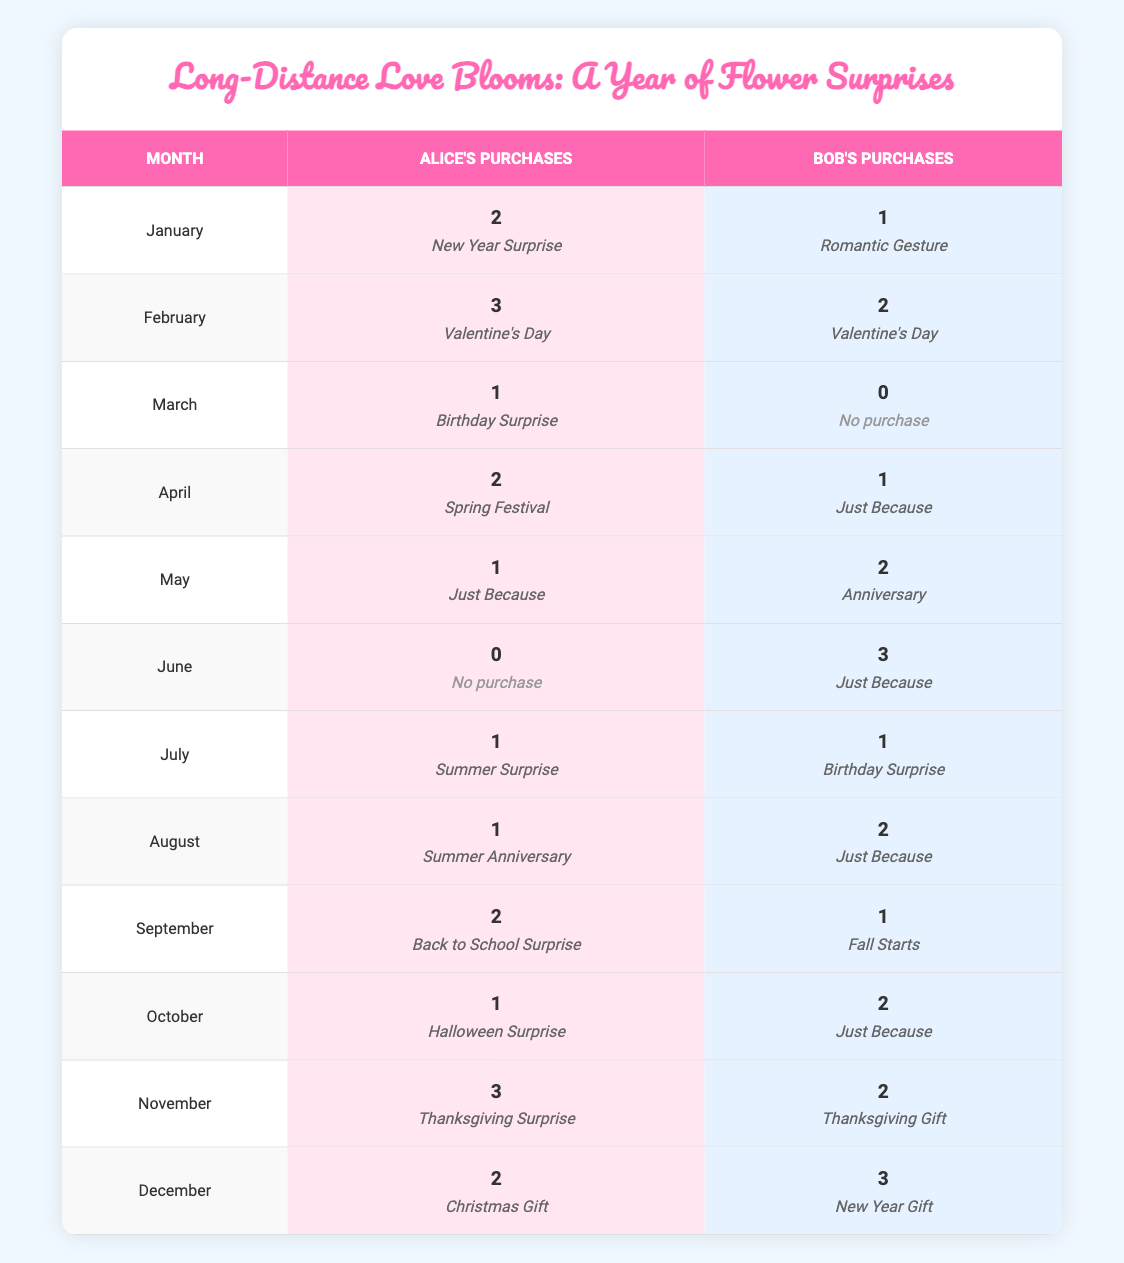What month did Alice purchase the most flowers? In January, Alice purchased 2 flowers; in February, she purchased 3 flowers, which is the highest for her.
Answer: February Did Bob make any purchases in March? In March, Bob's amount is 0, indicating he did not make any purchases.
Answer: No How many total flowers did Alice purchase in the first half of the year? For the first half of the year, Alice purchased: January (2) + February (3) + March (1) + April (2) + May (1) + June (0) = 9 flowers total.
Answer: 9 Who purchased more flowers in October, Alice or Bob? In October, Alice purchased 1 flower while Bob purchased 2 flowers, meaning Bob purchased more than Alice.
Answer: Bob What was the total number of flower purchases made by both Alice and Bob in December? In December, Alice purchased 2 flowers and Bob purchased 3 flowers. Therefore, the total is 2 + 3 = 5 purchases.
Answer: 5 Was there a month where both Alice and Bob made no purchases? By reviewing the data, March shows Bob made 0 purchases, but Alice still purchased 1 flower. Therefore, there is no month where both did not purchase any flowers.
Answer: No What is the average number of flowers purchased by Bob across the entire year? Bob's purchases are: January (1) + February (2) + March (0) + April (1) + May (2) + June (3) + July (1) + August (2) + September (1) + October (2) + November (2) + December (3) = 18 flowers. There are 12 months, so the average is 18/12 = 1.5.
Answer: 1.5 In what month did Alice make the highest purchase on a single occasion? The highest single occasion for Alice was in February with 3 flowers for Valentine's Day, which is more than any other month.
Answer: February How many total occasions did Bob buy flowers for in the year? Counting the occasions, Bob had 12 months of purchases, therefore he bought flowers for a total of 12 occasions throughout the year.
Answer: 12 